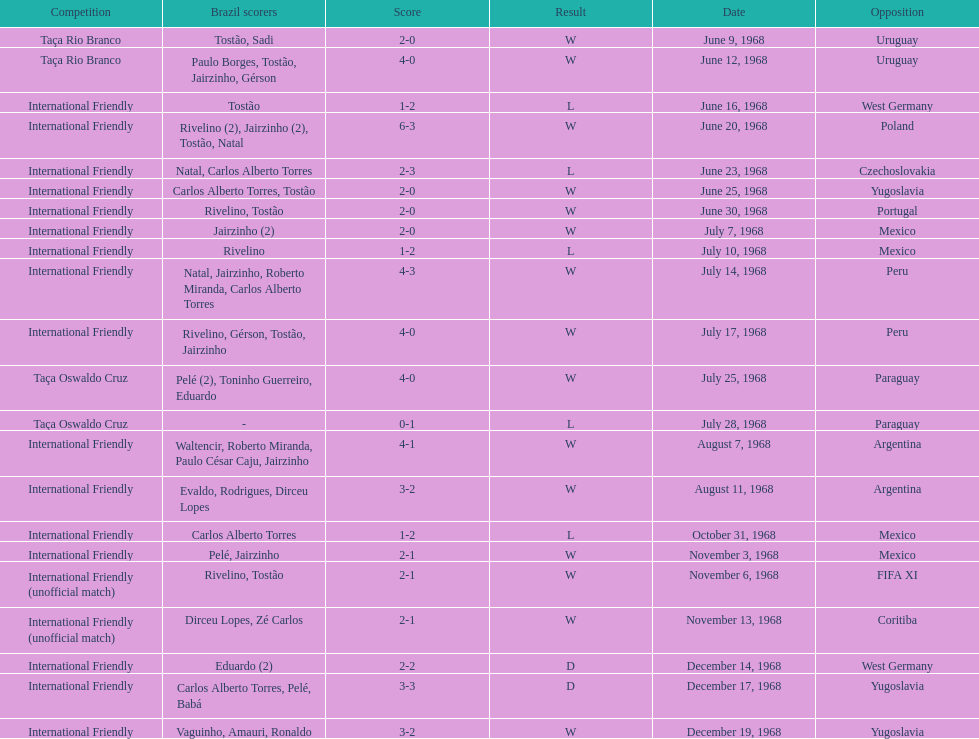Could you parse the entire table as a dict? {'header': ['Competition', 'Brazil scorers', 'Score', 'Result', 'Date', 'Opposition'], 'rows': [['Taça Rio Branco', 'Tostão, Sadi', '2-0', 'W', 'June 9, 1968', 'Uruguay'], ['Taça Rio Branco', 'Paulo Borges, Tostão, Jairzinho, Gérson', '4-0', 'W', 'June 12, 1968', 'Uruguay'], ['International Friendly', 'Tostão', '1-2', 'L', 'June 16, 1968', 'West Germany'], ['International Friendly', 'Rivelino (2), Jairzinho (2), Tostão, Natal', '6-3', 'W', 'June 20, 1968', 'Poland'], ['International Friendly', 'Natal, Carlos Alberto Torres', '2-3', 'L', 'June 23, 1968', 'Czechoslovakia'], ['International Friendly', 'Carlos Alberto Torres, Tostão', '2-0', 'W', 'June 25, 1968', 'Yugoslavia'], ['International Friendly', 'Rivelino, Tostão', '2-0', 'W', 'June 30, 1968', 'Portugal'], ['International Friendly', 'Jairzinho (2)', '2-0', 'W', 'July 7, 1968', 'Mexico'], ['International Friendly', 'Rivelino', '1-2', 'L', 'July 10, 1968', 'Mexico'], ['International Friendly', 'Natal, Jairzinho, Roberto Miranda, Carlos Alberto Torres', '4-3', 'W', 'July 14, 1968', 'Peru'], ['International Friendly', 'Rivelino, Gérson, Tostão, Jairzinho', '4-0', 'W', 'July 17, 1968', 'Peru'], ['Taça Oswaldo Cruz', 'Pelé (2), Toninho Guerreiro, Eduardo', '4-0', 'W', 'July 25, 1968', 'Paraguay'], ['Taça Oswaldo Cruz', '-', '0-1', 'L', 'July 28, 1968', 'Paraguay'], ['International Friendly', 'Waltencir, Roberto Miranda, Paulo César Caju, Jairzinho', '4-1', 'W', 'August 7, 1968', 'Argentina'], ['International Friendly', 'Evaldo, Rodrigues, Dirceu Lopes', '3-2', 'W', 'August 11, 1968', 'Argentina'], ['International Friendly', 'Carlos Alberto Torres', '1-2', 'L', 'October 31, 1968', 'Mexico'], ['International Friendly', 'Pelé, Jairzinho', '2-1', 'W', 'November 3, 1968', 'Mexico'], ['International Friendly (unofficial match)', 'Rivelino, Tostão', '2-1', 'W', 'November 6, 1968', 'FIFA XI'], ['International Friendly (unofficial match)', 'Dirceu Lopes, Zé Carlos', '2-1', 'W', 'November 13, 1968', 'Coritiba'], ['International Friendly', 'Eduardo (2)', '2-2', 'D', 'December 14, 1968', 'West Germany'], ['International Friendly', 'Carlos Alberto Torres, Pelé, Babá', '3-3', 'D', 'December 17, 1968', 'Yugoslavia'], ['International Friendly', 'Vaguinho, Amauri, Ronaldo', '3-2', 'W', 'December 19, 1968', 'Yugoslavia']]} What is the number of countries they have played? 11. 